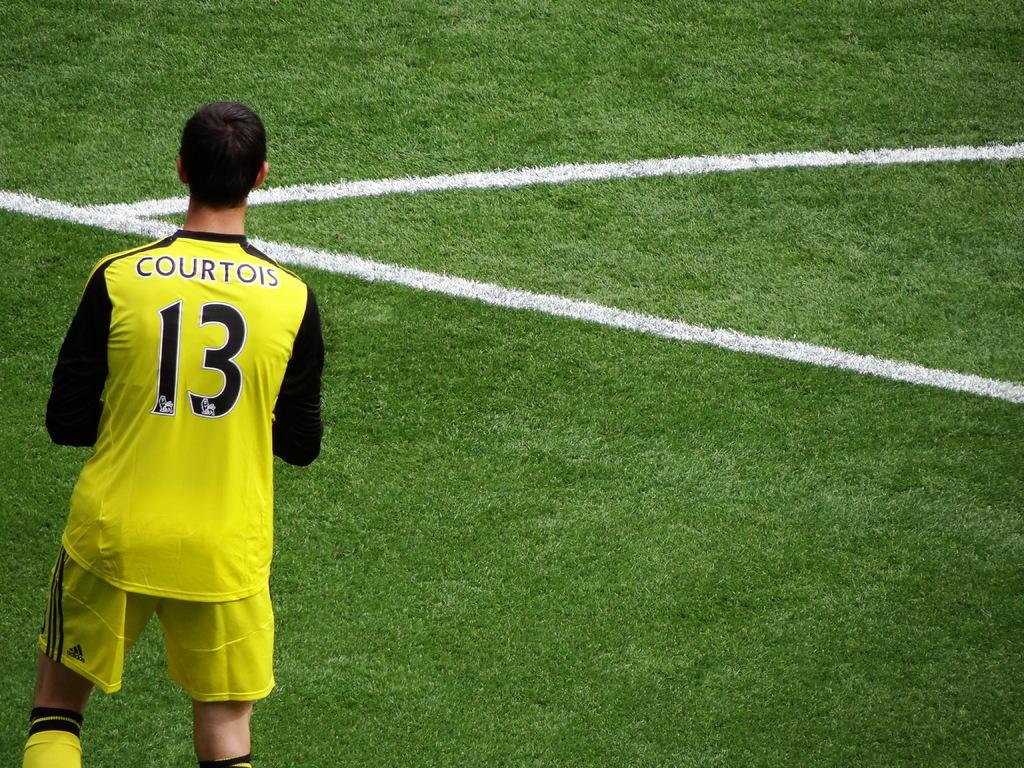<image>
Render a clear and concise summary of the photo. A soccer player with a yellow and black jersey, number 13. 